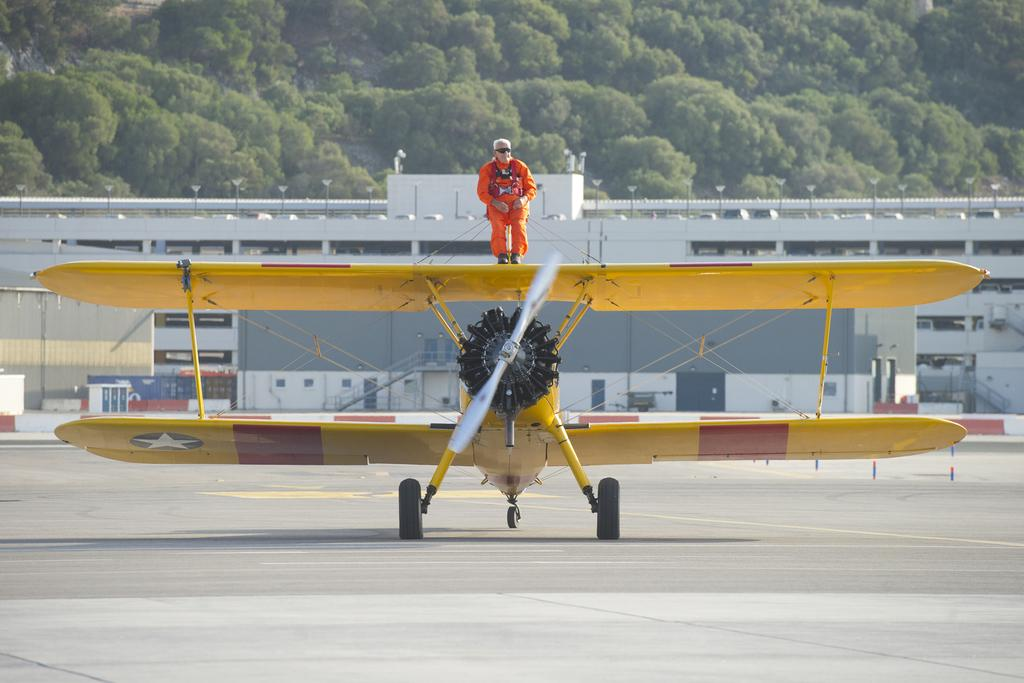What is the main subject of the picture? The main subject of the picture is a plane. Can you describe the person on the plane? Unfortunately, the person on the plane cannot be described in detail as the image does not provide enough information about them. What can be seen in the background of the picture? In the background of the picture, there are buildings and trees visible. Reasoning: Let' Let's think step by step in order to produce the conversation. We start by identifying the main subject of the image, which is the plane. Then, we mention the person on the plane, acknowledging that we cannot provide a detailed description due to the lack of information in the image. Finally, we describe the background of the image, which includes buildings and trees. Absurd Question/Answer: What invention is the person on the plane using to communicate with their pets? There is no mention of any invention or pets in the image, so it is impossible to answer this question. 